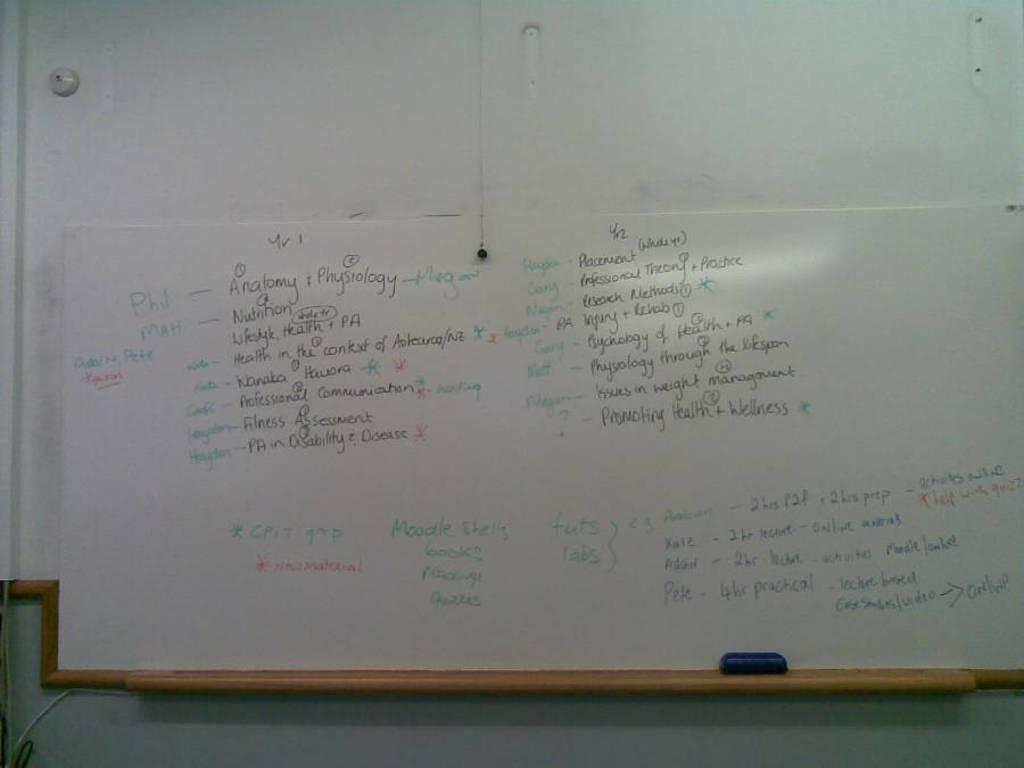<image>
Give a short and clear explanation of the subsequent image. School whiteboard with science notes written on it including anatomy. 